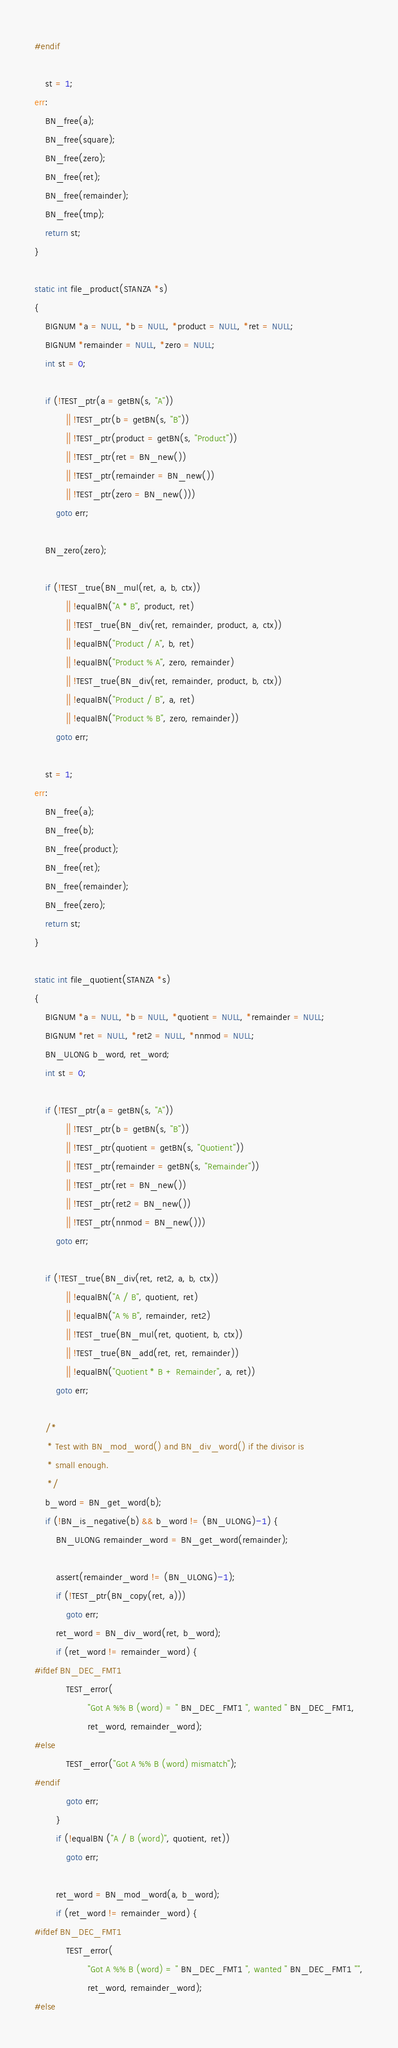<code> <loc_0><loc_0><loc_500><loc_500><_C_>#endif

    st = 1;
err:
    BN_free(a);
    BN_free(square);
    BN_free(zero);
    BN_free(ret);
    BN_free(remainder);
    BN_free(tmp);
    return st;
}

static int file_product(STANZA *s)
{
    BIGNUM *a = NULL, *b = NULL, *product = NULL, *ret = NULL;
    BIGNUM *remainder = NULL, *zero = NULL;
    int st = 0;

    if (!TEST_ptr(a = getBN(s, "A"))
            || !TEST_ptr(b = getBN(s, "B"))
            || !TEST_ptr(product = getBN(s, "Product"))
            || !TEST_ptr(ret = BN_new())
            || !TEST_ptr(remainder = BN_new())
            || !TEST_ptr(zero = BN_new()))
        goto err;

    BN_zero(zero);

    if (!TEST_true(BN_mul(ret, a, b, ctx))
            || !equalBN("A * B", product, ret)
            || !TEST_true(BN_div(ret, remainder, product, a, ctx))
            || !equalBN("Product / A", b, ret)
            || !equalBN("Product % A", zero, remainder)
            || !TEST_true(BN_div(ret, remainder, product, b, ctx))
            || !equalBN("Product / B", a, ret)
            || !equalBN("Product % B", zero, remainder))
        goto err;

    st = 1;
err:
    BN_free(a);
    BN_free(b);
    BN_free(product);
    BN_free(ret);
    BN_free(remainder);
    BN_free(zero);
    return st;
}

static int file_quotient(STANZA *s)
{
    BIGNUM *a = NULL, *b = NULL, *quotient = NULL, *remainder = NULL;
    BIGNUM *ret = NULL, *ret2 = NULL, *nnmod = NULL;
    BN_ULONG b_word, ret_word;
    int st = 0;

    if (!TEST_ptr(a = getBN(s, "A"))
            || !TEST_ptr(b = getBN(s, "B"))
            || !TEST_ptr(quotient = getBN(s, "Quotient"))
            || !TEST_ptr(remainder = getBN(s, "Remainder"))
            || !TEST_ptr(ret = BN_new())
            || !TEST_ptr(ret2 = BN_new())
            || !TEST_ptr(nnmod = BN_new()))
        goto err;

    if (!TEST_true(BN_div(ret, ret2, a, b, ctx))
            || !equalBN("A / B", quotient, ret)
            || !equalBN("A % B", remainder, ret2)
            || !TEST_true(BN_mul(ret, quotient, b, ctx))
            || !TEST_true(BN_add(ret, ret, remainder))
            || !equalBN("Quotient * B + Remainder", a, ret))
        goto err;

    /*
     * Test with BN_mod_word() and BN_div_word() if the divisor is
     * small enough.
     */
    b_word = BN_get_word(b);
    if (!BN_is_negative(b) && b_word != (BN_ULONG)-1) {
        BN_ULONG remainder_word = BN_get_word(remainder);

        assert(remainder_word != (BN_ULONG)-1);
        if (!TEST_ptr(BN_copy(ret, a)))
            goto err;
        ret_word = BN_div_word(ret, b_word);
        if (ret_word != remainder_word) {
#ifdef BN_DEC_FMT1
            TEST_error(
                    "Got A %% B (word) = " BN_DEC_FMT1 ", wanted " BN_DEC_FMT1,
                    ret_word, remainder_word);
#else
            TEST_error("Got A %% B (word) mismatch");
#endif
            goto err;
        }
        if (!equalBN ("A / B (word)", quotient, ret))
            goto err;

        ret_word = BN_mod_word(a, b_word);
        if (ret_word != remainder_word) {
#ifdef BN_DEC_FMT1
            TEST_error(
                    "Got A %% B (word) = " BN_DEC_FMT1 ", wanted " BN_DEC_FMT1 "",
                    ret_word, remainder_word);
#else</code> 